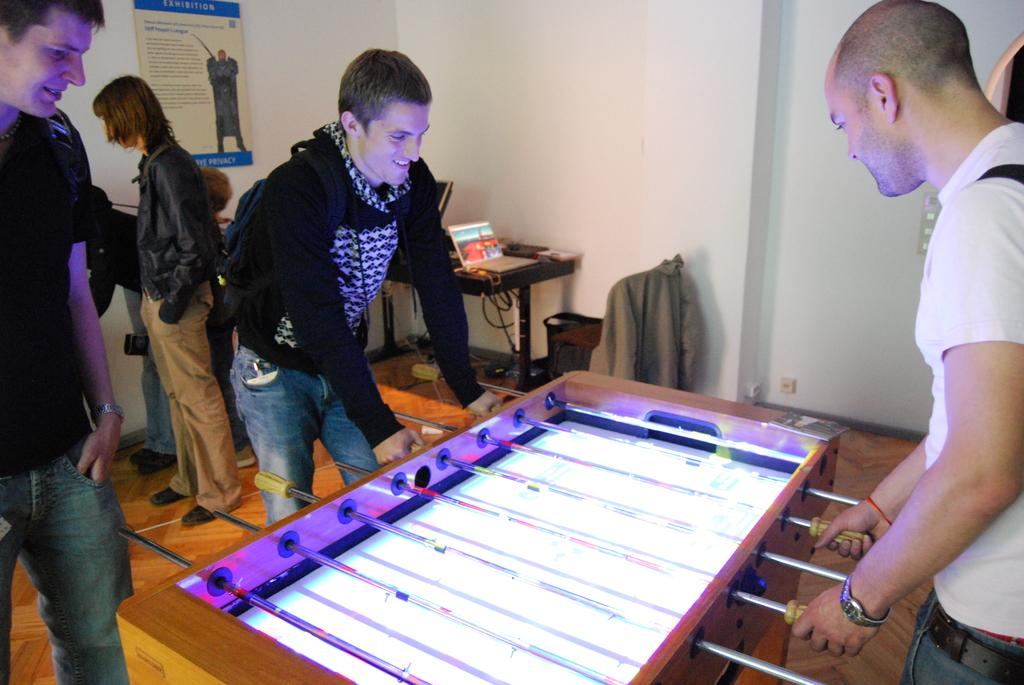What are the two persons in the image doing? The two persons in the image are playing Foosball. Is there anyone else in the image besides the players? Yes, there is a person standing and watching the game. What can be seen in the background of the image? There are people, a poster, and a wall in the background of the image. What type of beast can be seen in the image? There is no beast present in the image. How many clocks are visible in the image? There are no clocks visible in the image. 